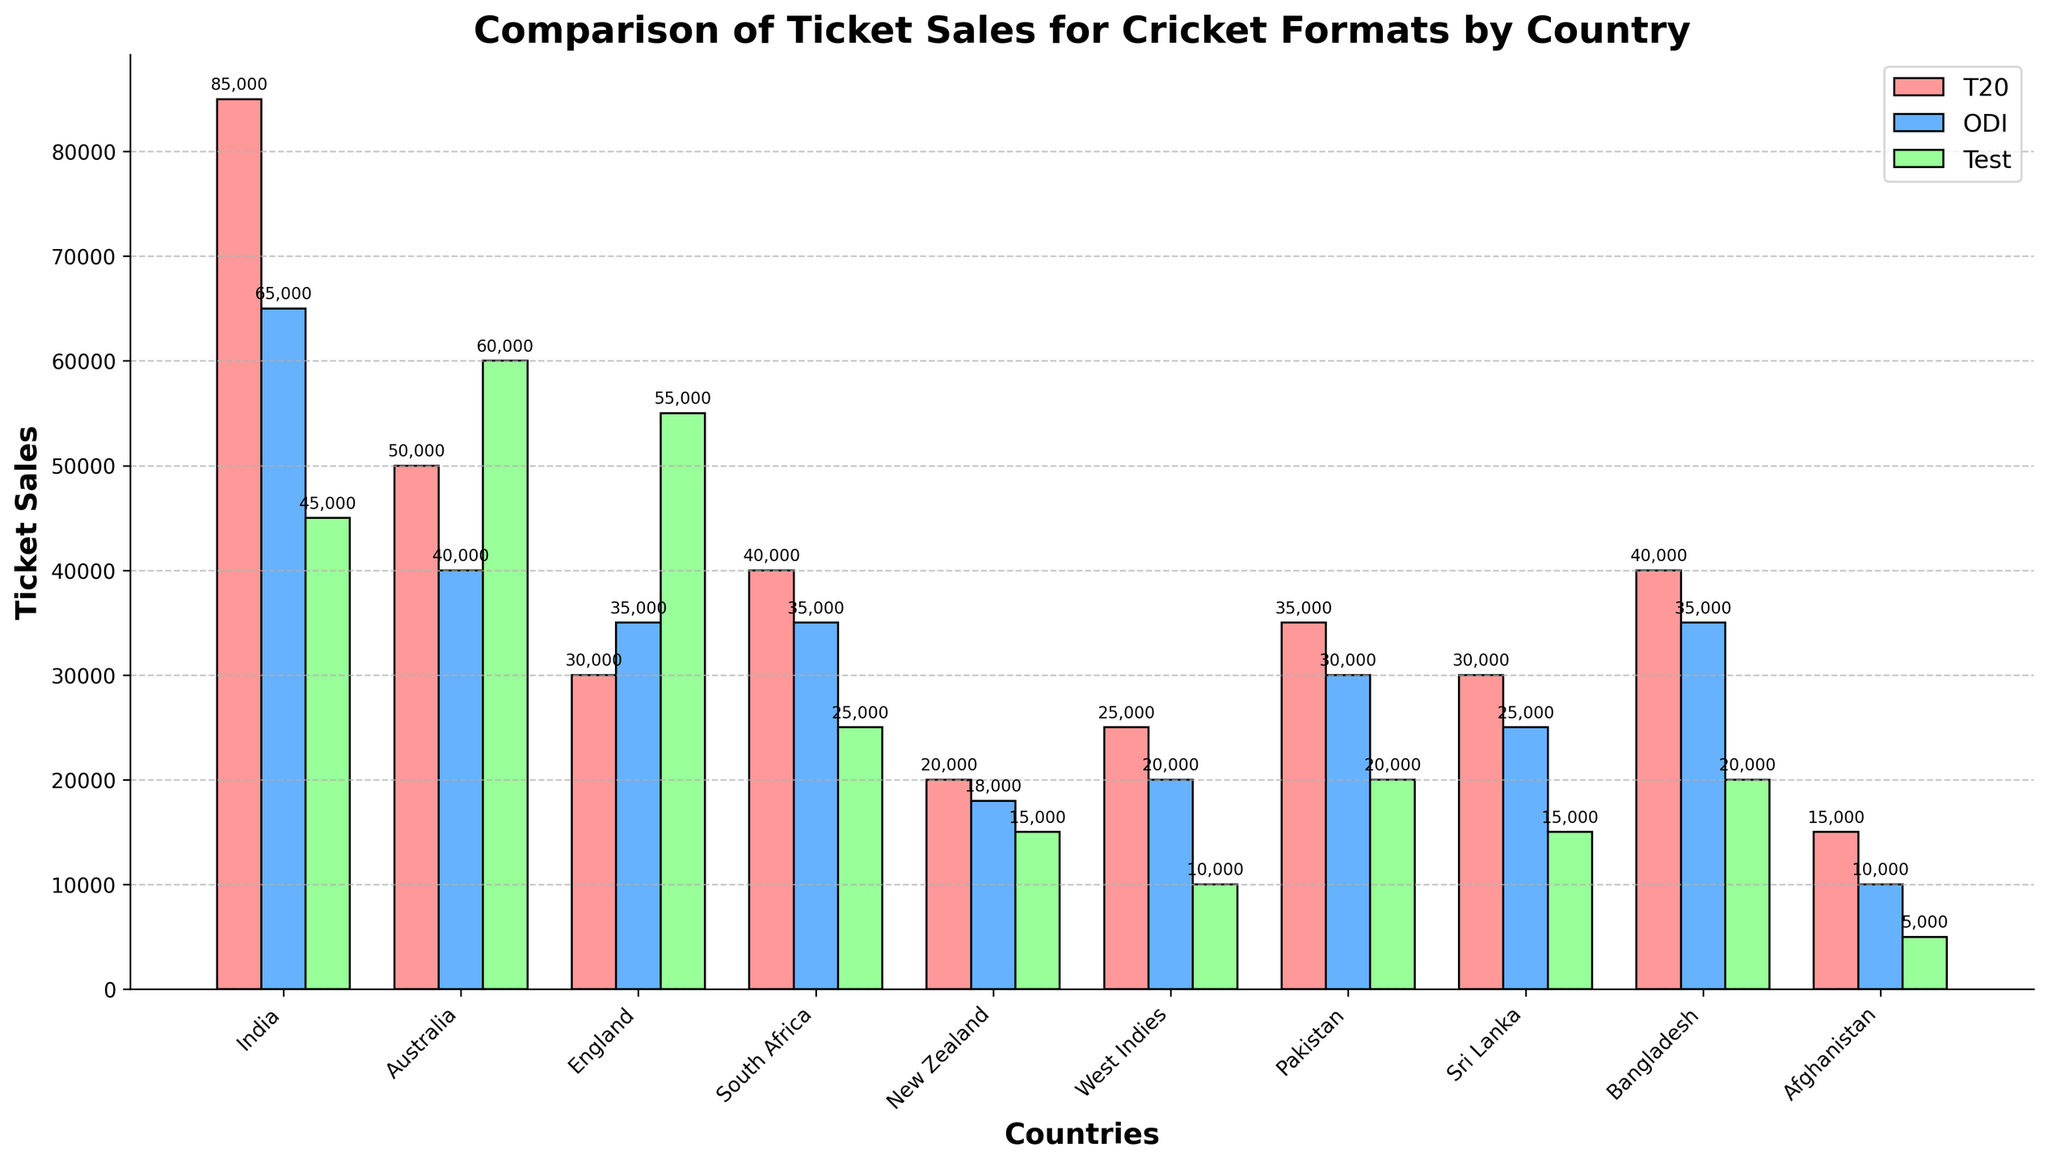Which country has the highest ticket sales for T20 matches? To find the country with the highest T20 ticket sales, visually compare the heights of the bars for T20 matches among all countries. India’s bar is the tallest.
Answer: India Which format has the least ticket sales in England? Look at the bars representing T20, ODI, and Test for England. The T20 bar is the shortest.
Answer: T20 What is the total ticket sales for Test matches in Australia and New Zealand combined? Add the ticket sales for Test matches in Australia and New Zealand: 60,000 (Australia) + 15,000 (New Zealand) = 75,000
Answer: 75,000 How do the ticket sales for ODI matches in Bangladesh compare to South Africa? Compare the heights of the ODI bars for Bangladesh and South Africa. They are equal.
Answer: Equal Which country has the most balanced ticket sales across the three formats? Compare the heights of the T20, ODI, and Test bars for each country. Australia has the most balanced ticket sales across all formats (50,000, 40,000, 60,000).
Answer: Australia What's the difference in ticket sales for Test matches between India and Pakistan? Subtract the ticket sales for Test matches in Pakistan from those in India: 45,000 (India) - 20,000 (Pakistan) = 25,000
Answer: 25,000 Which country shows an increasing trend from T20 to ODI to Test matches? Look for the countries where the heights of bars increase from T20 to ODI to Test. Australia shows this trend (50,000 to 40,000 to 60,000).
Answer: Australia Which format has the highest ticket sales in total across all countries? Sum the ticket sales for all countries in each format. T20: 435,000, ODI: 325,000; Test: 230,000. T20 has the highest total.
Answer: T20 What's the average ticket sales for ODI matches across all countries? Sum the ODI ticket sales and divide by the number of countries. Total ODI sales are 325,000 across 10 countries. Average = 325,000 / 10 = 32,500
Answer: 32,500 